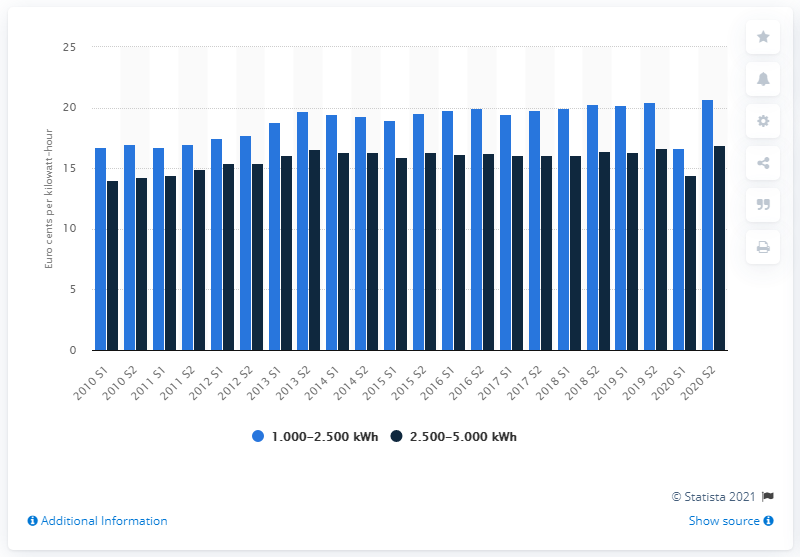Point out several critical features in this image. The lowest electricity price in Slovenia during the first half of 2020 was 14.48 cents per kilowatt-hour. 